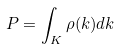Convert formula to latex. <formula><loc_0><loc_0><loc_500><loc_500>P = \int _ { K } \rho ( k ) d k</formula> 